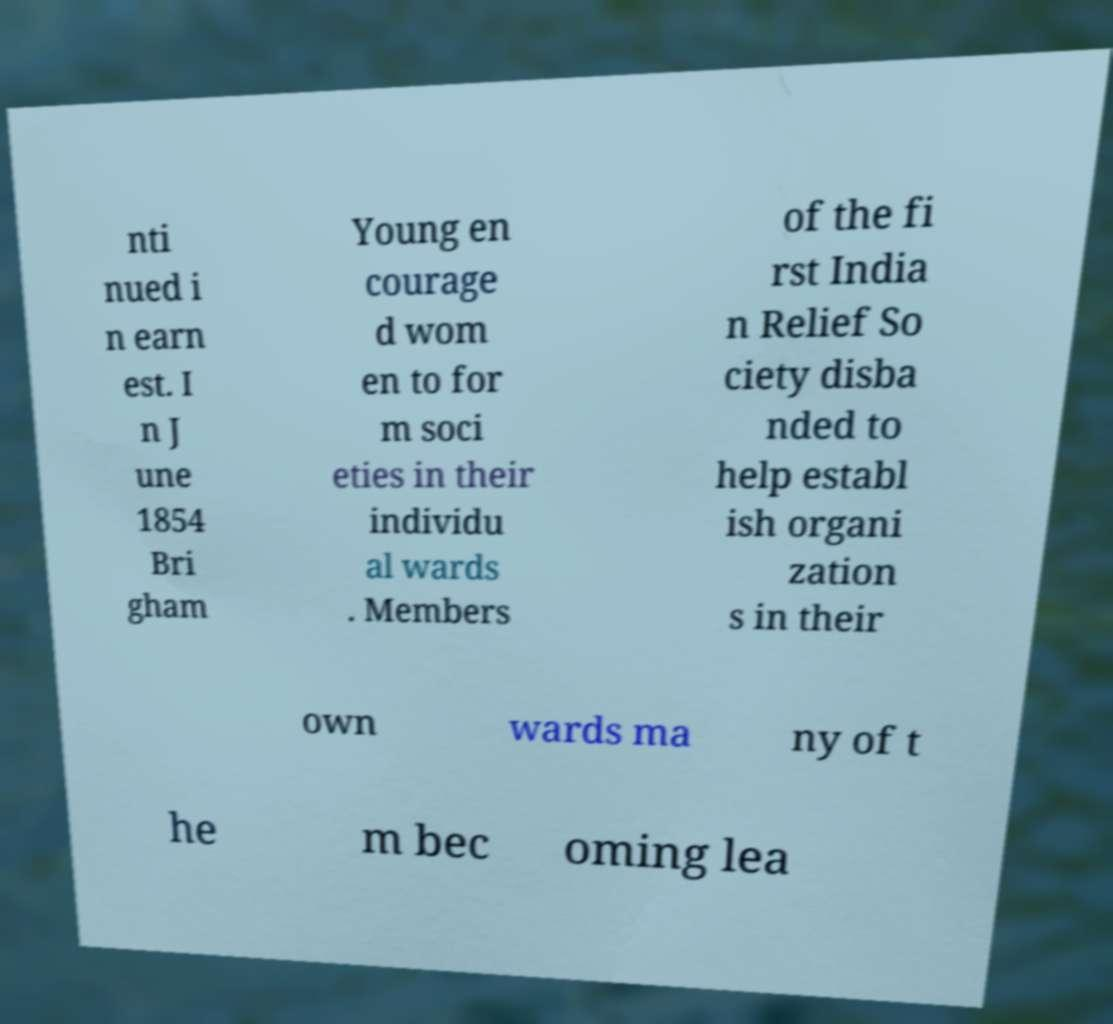I need the written content from this picture converted into text. Can you do that? nti nued i n earn est. I n J une 1854 Bri gham Young en courage d wom en to for m soci eties in their individu al wards . Members of the fi rst India n Relief So ciety disba nded to help establ ish organi zation s in their own wards ma ny of t he m bec oming lea 